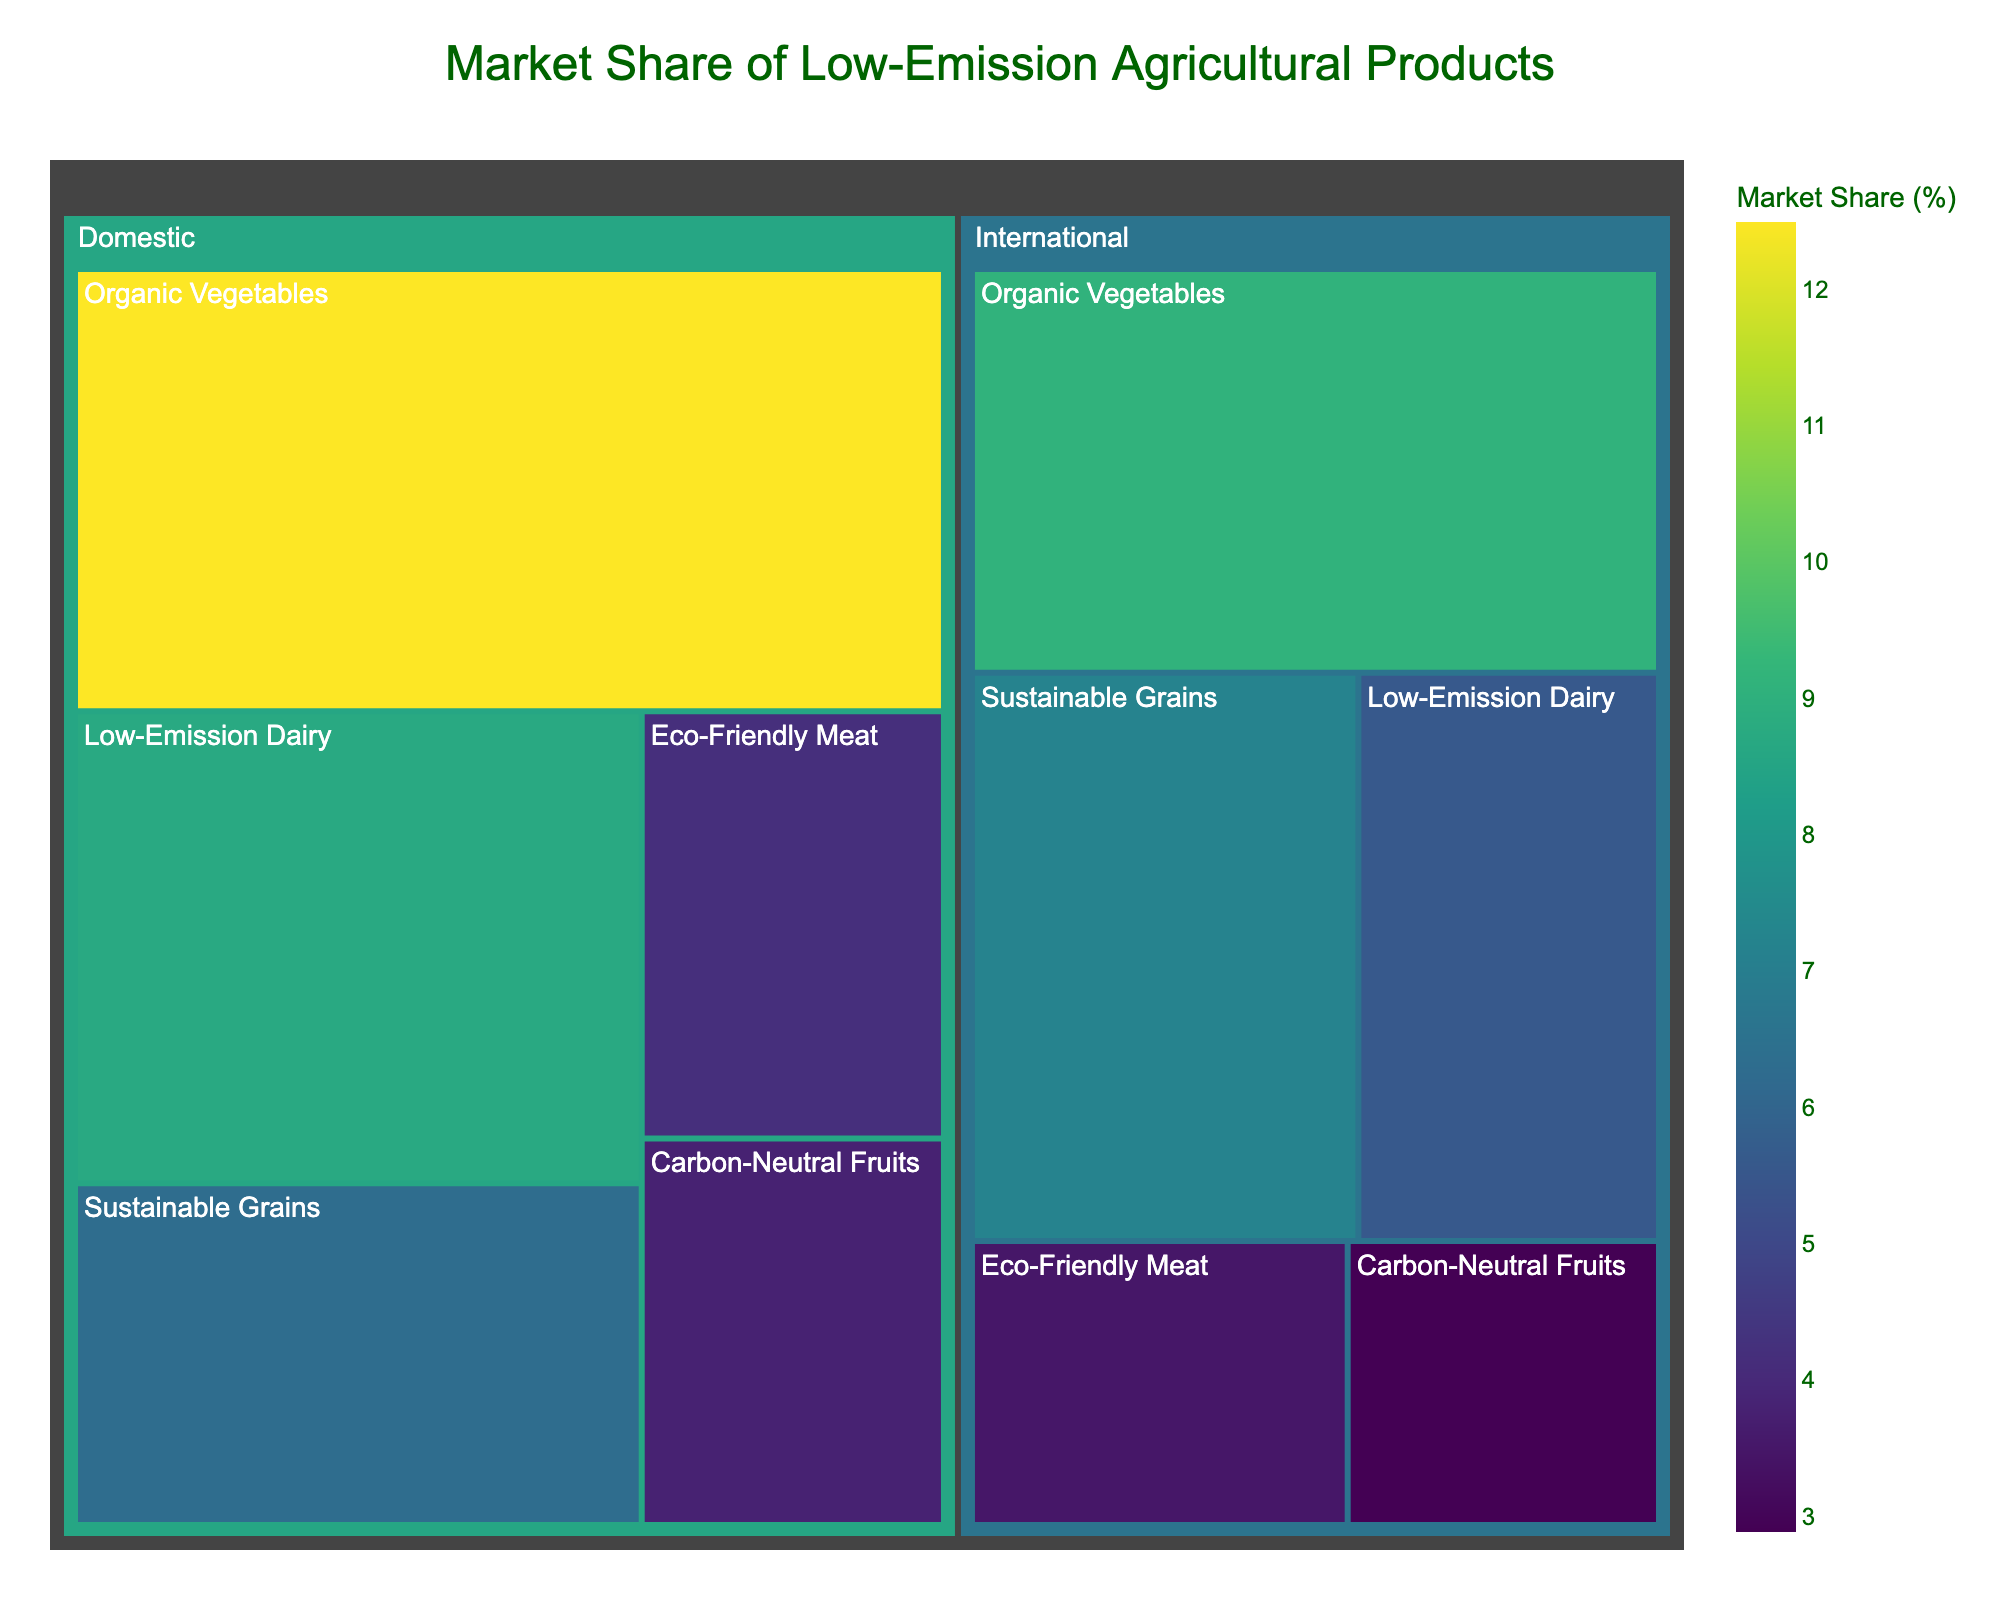What's the title of the figure? The title of the figure is located at the top and often summarizes the content or context of the data being displayed in a concise manner.
Answer: Market Share of Low-Emission Agricultural Products How many product categories are present in the domestic market? The different product categories are distinguished by the labels within the Domestic section. Count each unique label to find the total number.
Answer: 5 Which product category has the smallest market share in the international market? Look at the sections under the International category and identify the one with the smallest allocated space and value.
Answer: Carbon-Neutral Fruits What is the combined market share of Sustainable Grains in both markets? Add the market shares for Sustainable Grains from both Domestic and International segments. 6.3% from Domestic and 7.2% from International sum up to 13.5%.
Answer: 13.5% Compare the market share of Organic Vegetables in the domestic and international markets. Identify the market shares for Organic Vegetables under both categories and compare them. 12.5% in Domestic and 9.1% in International.
Answer: Higher in Domestic What is the difference in market share between Low-Emission Dairy in the domestic and international markets? Subtract the market share of Low-Emission Dairy in the International market from that in the Domestic market. 8.7% - 5.6% = 3.1%.
Answer: 3.1% Which market has a higher total market share for Eco-Friendly Meat? Compare the market shares of Eco-Friendly Meat in the Domestic and International segments. 4.2% in Domestic and 3.5% in International.
Answer: Domestic What are the market shares for Carbon-Neutral Fruits across both markets? Look for the market share values of Carbon-Neutral Fruits in both Domestic and International segments. 3.8% in Domestic and 2.9% in International.
Answer: 3.8% Domestic, 2.9% International Identify the product category with the highest market share across both markets. Review all segments to find the product category with the highest single market share value. Organic Vegetables have the highest share in the Domestic segment with 12.5%.
Answer: Organic Vegetables in Domestic What is the average market share of Low-Emission Dairy products across both markets? Add the market shares of Low-Emission Dairy in Domestic and International markets, then divide by 2. (8.7% + 5.6%) / 2 = 7.15%.
Answer: 7.15% 